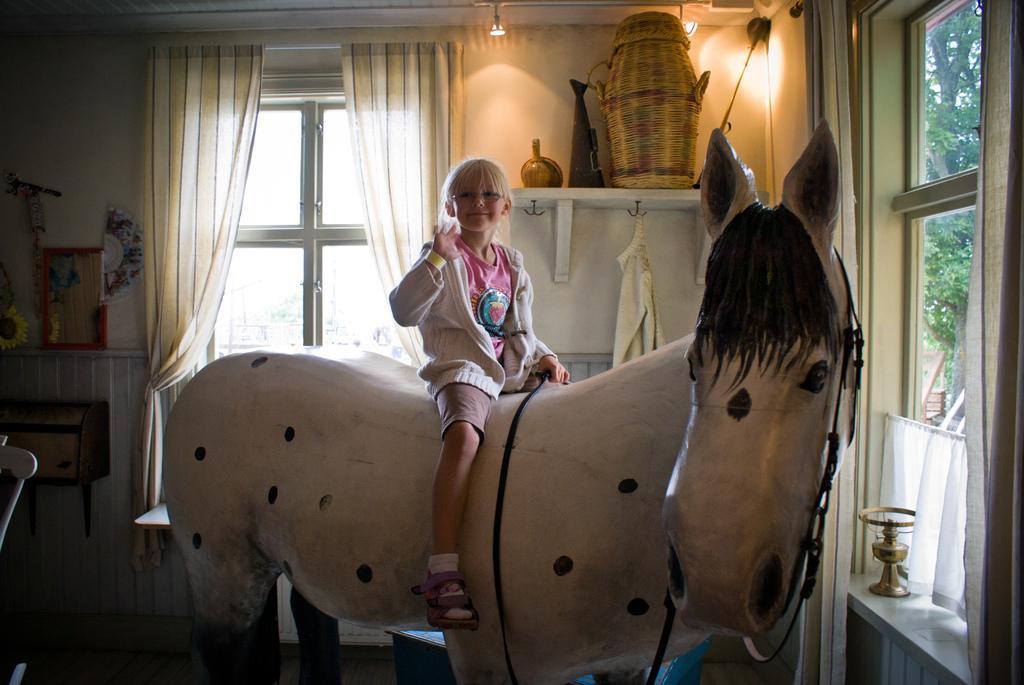Can you describe this image briefly? Here we can see a child sitting on a horse doll and behind her we can see window and curtains and in front of her also we can see Window and greenery outside 